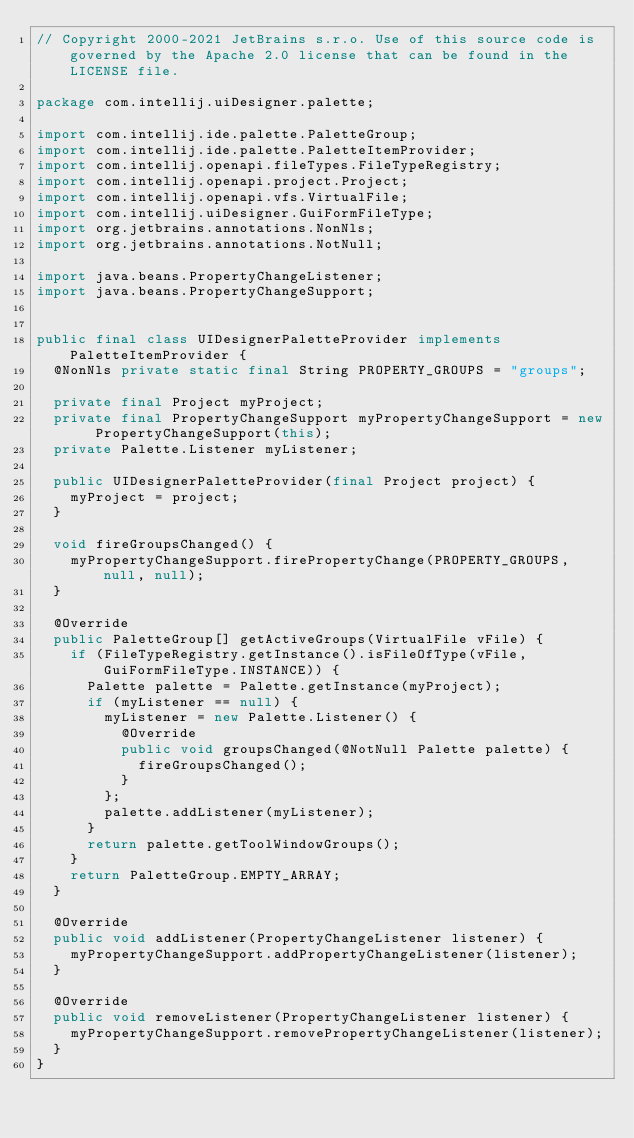Convert code to text. <code><loc_0><loc_0><loc_500><loc_500><_Java_>// Copyright 2000-2021 JetBrains s.r.o. Use of this source code is governed by the Apache 2.0 license that can be found in the LICENSE file.

package com.intellij.uiDesigner.palette;

import com.intellij.ide.palette.PaletteGroup;
import com.intellij.ide.palette.PaletteItemProvider;
import com.intellij.openapi.fileTypes.FileTypeRegistry;
import com.intellij.openapi.project.Project;
import com.intellij.openapi.vfs.VirtualFile;
import com.intellij.uiDesigner.GuiFormFileType;
import org.jetbrains.annotations.NonNls;
import org.jetbrains.annotations.NotNull;

import java.beans.PropertyChangeListener;
import java.beans.PropertyChangeSupport;


public final class UIDesignerPaletteProvider implements PaletteItemProvider {
  @NonNls private static final String PROPERTY_GROUPS = "groups";

  private final Project myProject;
  private final PropertyChangeSupport myPropertyChangeSupport = new PropertyChangeSupport(this);
  private Palette.Listener myListener;

  public UIDesignerPaletteProvider(final Project project) {
    myProject = project;
  }

  void fireGroupsChanged() {
    myPropertyChangeSupport.firePropertyChange(PROPERTY_GROUPS, null, null);
  }

  @Override
  public PaletteGroup[] getActiveGroups(VirtualFile vFile) {
    if (FileTypeRegistry.getInstance().isFileOfType(vFile, GuiFormFileType.INSTANCE)) {
      Palette palette = Palette.getInstance(myProject);
      if (myListener == null) {
        myListener = new Palette.Listener() {
          @Override
          public void groupsChanged(@NotNull Palette palette) {
            fireGroupsChanged();
          }
        };
        palette.addListener(myListener);
      }
      return palette.getToolWindowGroups();
    }
    return PaletteGroup.EMPTY_ARRAY;
  }

  @Override
  public void addListener(PropertyChangeListener listener) {
    myPropertyChangeSupport.addPropertyChangeListener(listener);
  }

  @Override
  public void removeListener(PropertyChangeListener listener) {
    myPropertyChangeSupport.removePropertyChangeListener(listener);
  }
}
</code> 